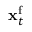Convert formula to latex. <formula><loc_0><loc_0><loc_500><loc_500>{ x } _ { t } ^ { f }</formula> 